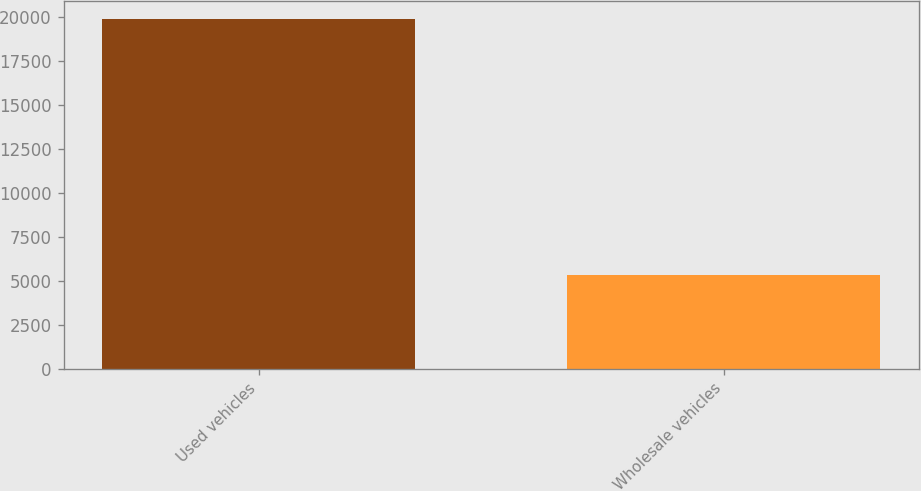Convert chart. <chart><loc_0><loc_0><loc_500><loc_500><bar_chart><fcel>Used vehicles<fcel>Wholesale vehicles<nl><fcel>19917<fcel>5327<nl></chart> 